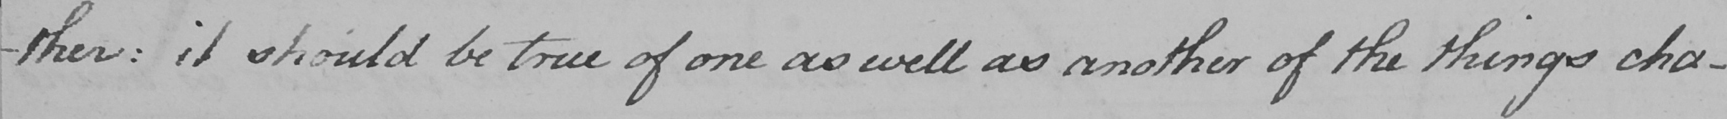What text is written in this handwritten line? -ther :  it should be true of one as well as another of the things cha- 